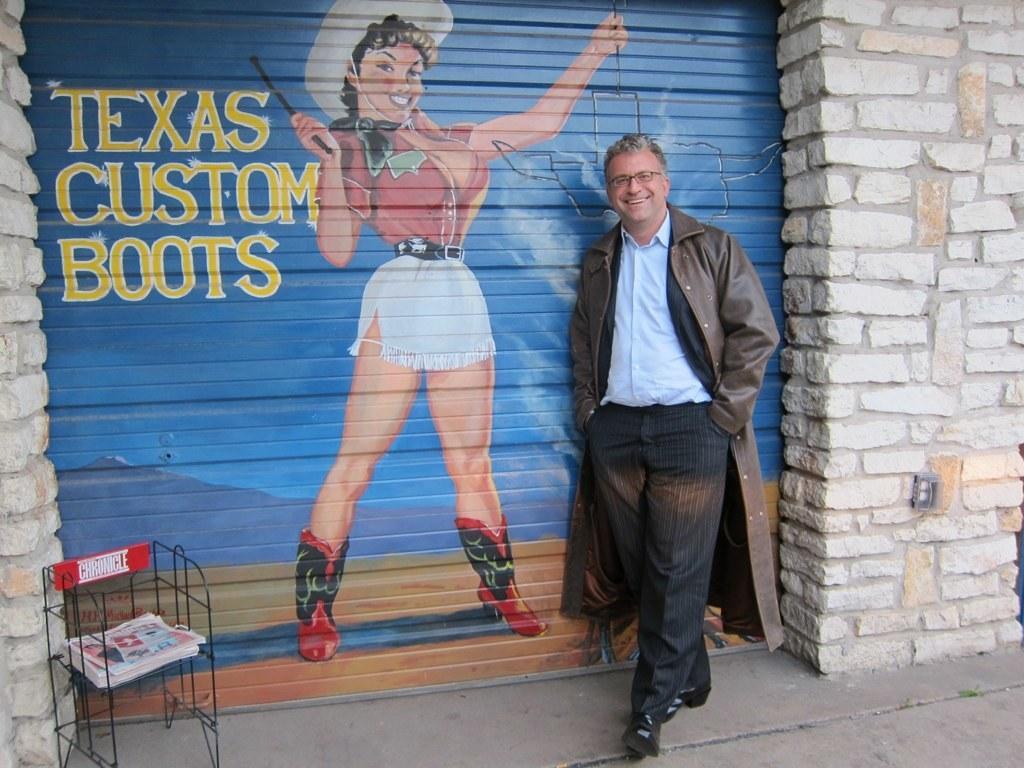Describe this image in one or two sentences. In this image a person wearing a jacket is standing beside a shutter having a painting of a woman and some text. Before it there is a stand having few papers in it which is on the floor. Right side there is a wall. 